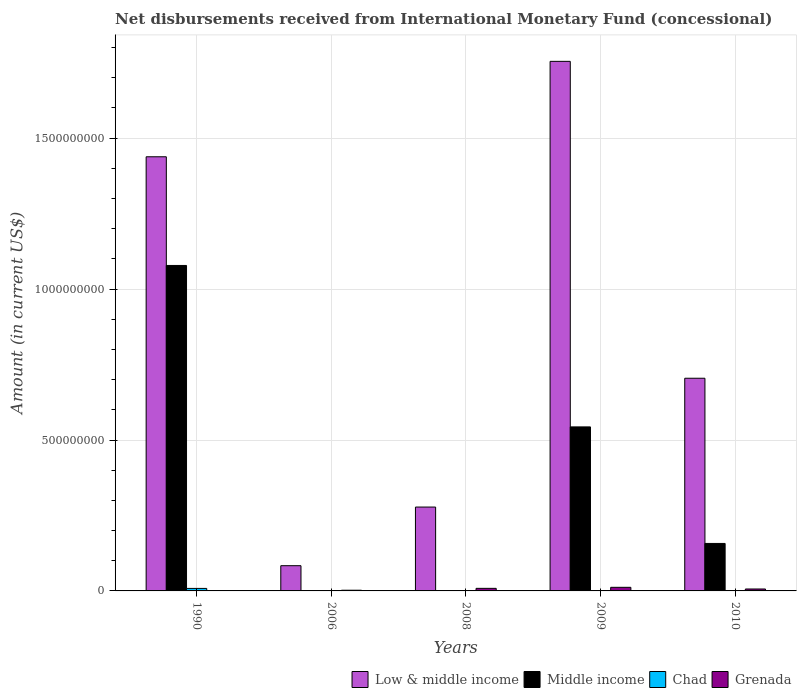How many different coloured bars are there?
Your answer should be very brief. 4. Are the number of bars per tick equal to the number of legend labels?
Ensure brevity in your answer.  No. How many bars are there on the 2nd tick from the left?
Offer a terse response. 2. How many bars are there on the 2nd tick from the right?
Your response must be concise. 3. What is the label of the 5th group of bars from the left?
Your response must be concise. 2010. In how many cases, is the number of bars for a given year not equal to the number of legend labels?
Offer a very short reply. 5. What is the amount of disbursements received from International Monetary Fund in Grenada in 2008?
Provide a succinct answer. 8.52e+06. Across all years, what is the maximum amount of disbursements received from International Monetary Fund in Low & middle income?
Keep it short and to the point. 1.75e+09. Across all years, what is the minimum amount of disbursements received from International Monetary Fund in Low & middle income?
Provide a succinct answer. 8.36e+07. In which year was the amount of disbursements received from International Monetary Fund in Chad maximum?
Keep it short and to the point. 1990. What is the total amount of disbursements received from International Monetary Fund in Chad in the graph?
Offer a terse response. 8.31e+06. What is the difference between the amount of disbursements received from International Monetary Fund in Middle income in 2009 and that in 2010?
Provide a short and direct response. 3.86e+08. What is the difference between the amount of disbursements received from International Monetary Fund in Low & middle income in 2008 and the amount of disbursements received from International Monetary Fund in Middle income in 2006?
Make the answer very short. 2.78e+08. What is the average amount of disbursements received from International Monetary Fund in Low & middle income per year?
Provide a short and direct response. 8.52e+08. In the year 2010, what is the difference between the amount of disbursements received from International Monetary Fund in Low & middle income and amount of disbursements received from International Monetary Fund in Grenada?
Provide a succinct answer. 6.98e+08. In how many years, is the amount of disbursements received from International Monetary Fund in Low & middle income greater than 900000000 US$?
Ensure brevity in your answer.  2. What is the ratio of the amount of disbursements received from International Monetary Fund in Low & middle income in 2008 to that in 2010?
Your answer should be compact. 0.39. Is the amount of disbursements received from International Monetary Fund in Low & middle income in 1990 less than that in 2010?
Make the answer very short. No. What is the difference between the highest and the second highest amount of disbursements received from International Monetary Fund in Middle income?
Offer a terse response. 5.35e+08. What is the difference between the highest and the lowest amount of disbursements received from International Monetary Fund in Grenada?
Keep it short and to the point. 1.20e+07. In how many years, is the amount of disbursements received from International Monetary Fund in Low & middle income greater than the average amount of disbursements received from International Monetary Fund in Low & middle income taken over all years?
Ensure brevity in your answer.  2. Is it the case that in every year, the sum of the amount of disbursements received from International Monetary Fund in Low & middle income and amount of disbursements received from International Monetary Fund in Chad is greater than the sum of amount of disbursements received from International Monetary Fund in Grenada and amount of disbursements received from International Monetary Fund in Middle income?
Your response must be concise. Yes. Are all the bars in the graph horizontal?
Offer a very short reply. No. What is the difference between two consecutive major ticks on the Y-axis?
Your response must be concise. 5.00e+08. Are the values on the major ticks of Y-axis written in scientific E-notation?
Keep it short and to the point. No. How many legend labels are there?
Offer a very short reply. 4. What is the title of the graph?
Your answer should be very brief. Net disbursements received from International Monetary Fund (concessional). Does "France" appear as one of the legend labels in the graph?
Keep it short and to the point. No. What is the label or title of the Y-axis?
Make the answer very short. Amount (in current US$). What is the Amount (in current US$) of Low & middle income in 1990?
Make the answer very short. 1.44e+09. What is the Amount (in current US$) of Middle income in 1990?
Keep it short and to the point. 1.08e+09. What is the Amount (in current US$) in Chad in 1990?
Your answer should be compact. 8.31e+06. What is the Amount (in current US$) of Grenada in 1990?
Keep it short and to the point. 0. What is the Amount (in current US$) of Low & middle income in 2006?
Offer a very short reply. 8.36e+07. What is the Amount (in current US$) of Grenada in 2006?
Your response must be concise. 2.30e+06. What is the Amount (in current US$) of Low & middle income in 2008?
Give a very brief answer. 2.78e+08. What is the Amount (in current US$) of Middle income in 2008?
Your answer should be very brief. 0. What is the Amount (in current US$) of Chad in 2008?
Provide a short and direct response. 0. What is the Amount (in current US$) of Grenada in 2008?
Offer a very short reply. 8.52e+06. What is the Amount (in current US$) in Low & middle income in 2009?
Offer a very short reply. 1.75e+09. What is the Amount (in current US$) in Middle income in 2009?
Keep it short and to the point. 5.43e+08. What is the Amount (in current US$) in Grenada in 2009?
Your answer should be compact. 1.20e+07. What is the Amount (in current US$) of Low & middle income in 2010?
Offer a very short reply. 7.05e+08. What is the Amount (in current US$) in Middle income in 2010?
Make the answer very short. 1.57e+08. What is the Amount (in current US$) of Grenada in 2010?
Your answer should be very brief. 6.42e+06. Across all years, what is the maximum Amount (in current US$) of Low & middle income?
Give a very brief answer. 1.75e+09. Across all years, what is the maximum Amount (in current US$) of Middle income?
Provide a short and direct response. 1.08e+09. Across all years, what is the maximum Amount (in current US$) of Chad?
Your answer should be compact. 8.31e+06. Across all years, what is the maximum Amount (in current US$) of Grenada?
Keep it short and to the point. 1.20e+07. Across all years, what is the minimum Amount (in current US$) of Low & middle income?
Ensure brevity in your answer.  8.36e+07. What is the total Amount (in current US$) in Low & middle income in the graph?
Provide a succinct answer. 4.26e+09. What is the total Amount (in current US$) of Middle income in the graph?
Provide a succinct answer. 1.78e+09. What is the total Amount (in current US$) of Chad in the graph?
Provide a succinct answer. 8.31e+06. What is the total Amount (in current US$) of Grenada in the graph?
Make the answer very short. 2.92e+07. What is the difference between the Amount (in current US$) of Low & middle income in 1990 and that in 2006?
Provide a succinct answer. 1.35e+09. What is the difference between the Amount (in current US$) in Low & middle income in 1990 and that in 2008?
Your answer should be very brief. 1.16e+09. What is the difference between the Amount (in current US$) in Low & middle income in 1990 and that in 2009?
Make the answer very short. -3.16e+08. What is the difference between the Amount (in current US$) of Middle income in 1990 and that in 2009?
Make the answer very short. 5.35e+08. What is the difference between the Amount (in current US$) of Low & middle income in 1990 and that in 2010?
Make the answer very short. 7.34e+08. What is the difference between the Amount (in current US$) of Middle income in 1990 and that in 2010?
Your answer should be very brief. 9.21e+08. What is the difference between the Amount (in current US$) in Low & middle income in 2006 and that in 2008?
Provide a short and direct response. -1.94e+08. What is the difference between the Amount (in current US$) in Grenada in 2006 and that in 2008?
Keep it short and to the point. -6.22e+06. What is the difference between the Amount (in current US$) in Low & middle income in 2006 and that in 2009?
Offer a very short reply. -1.67e+09. What is the difference between the Amount (in current US$) in Grenada in 2006 and that in 2009?
Offer a very short reply. -9.66e+06. What is the difference between the Amount (in current US$) of Low & middle income in 2006 and that in 2010?
Provide a short and direct response. -6.21e+08. What is the difference between the Amount (in current US$) in Grenada in 2006 and that in 2010?
Your answer should be very brief. -4.12e+06. What is the difference between the Amount (in current US$) of Low & middle income in 2008 and that in 2009?
Give a very brief answer. -1.48e+09. What is the difference between the Amount (in current US$) of Grenada in 2008 and that in 2009?
Offer a very short reply. -3.43e+06. What is the difference between the Amount (in current US$) of Low & middle income in 2008 and that in 2010?
Ensure brevity in your answer.  -4.27e+08. What is the difference between the Amount (in current US$) in Grenada in 2008 and that in 2010?
Your answer should be very brief. 2.10e+06. What is the difference between the Amount (in current US$) in Low & middle income in 2009 and that in 2010?
Your response must be concise. 1.05e+09. What is the difference between the Amount (in current US$) in Middle income in 2009 and that in 2010?
Provide a succinct answer. 3.86e+08. What is the difference between the Amount (in current US$) in Grenada in 2009 and that in 2010?
Make the answer very short. 5.54e+06. What is the difference between the Amount (in current US$) of Low & middle income in 1990 and the Amount (in current US$) of Grenada in 2006?
Provide a succinct answer. 1.44e+09. What is the difference between the Amount (in current US$) of Middle income in 1990 and the Amount (in current US$) of Grenada in 2006?
Your answer should be very brief. 1.08e+09. What is the difference between the Amount (in current US$) in Chad in 1990 and the Amount (in current US$) in Grenada in 2006?
Give a very brief answer. 6.01e+06. What is the difference between the Amount (in current US$) of Low & middle income in 1990 and the Amount (in current US$) of Grenada in 2008?
Offer a terse response. 1.43e+09. What is the difference between the Amount (in current US$) of Middle income in 1990 and the Amount (in current US$) of Grenada in 2008?
Keep it short and to the point. 1.07e+09. What is the difference between the Amount (in current US$) in Chad in 1990 and the Amount (in current US$) in Grenada in 2008?
Give a very brief answer. -2.11e+05. What is the difference between the Amount (in current US$) of Low & middle income in 1990 and the Amount (in current US$) of Middle income in 2009?
Your answer should be very brief. 8.95e+08. What is the difference between the Amount (in current US$) in Low & middle income in 1990 and the Amount (in current US$) in Grenada in 2009?
Keep it short and to the point. 1.43e+09. What is the difference between the Amount (in current US$) of Middle income in 1990 and the Amount (in current US$) of Grenada in 2009?
Your answer should be very brief. 1.07e+09. What is the difference between the Amount (in current US$) of Chad in 1990 and the Amount (in current US$) of Grenada in 2009?
Provide a succinct answer. -3.64e+06. What is the difference between the Amount (in current US$) in Low & middle income in 1990 and the Amount (in current US$) in Middle income in 2010?
Your response must be concise. 1.28e+09. What is the difference between the Amount (in current US$) in Low & middle income in 1990 and the Amount (in current US$) in Grenada in 2010?
Give a very brief answer. 1.43e+09. What is the difference between the Amount (in current US$) of Middle income in 1990 and the Amount (in current US$) of Grenada in 2010?
Offer a very short reply. 1.07e+09. What is the difference between the Amount (in current US$) in Chad in 1990 and the Amount (in current US$) in Grenada in 2010?
Your response must be concise. 1.89e+06. What is the difference between the Amount (in current US$) of Low & middle income in 2006 and the Amount (in current US$) of Grenada in 2008?
Give a very brief answer. 7.50e+07. What is the difference between the Amount (in current US$) in Low & middle income in 2006 and the Amount (in current US$) in Middle income in 2009?
Offer a terse response. -4.60e+08. What is the difference between the Amount (in current US$) in Low & middle income in 2006 and the Amount (in current US$) in Grenada in 2009?
Give a very brief answer. 7.16e+07. What is the difference between the Amount (in current US$) of Low & middle income in 2006 and the Amount (in current US$) of Middle income in 2010?
Your response must be concise. -7.37e+07. What is the difference between the Amount (in current US$) of Low & middle income in 2006 and the Amount (in current US$) of Grenada in 2010?
Provide a succinct answer. 7.71e+07. What is the difference between the Amount (in current US$) of Low & middle income in 2008 and the Amount (in current US$) of Middle income in 2009?
Your answer should be compact. -2.66e+08. What is the difference between the Amount (in current US$) of Low & middle income in 2008 and the Amount (in current US$) of Grenada in 2009?
Make the answer very short. 2.66e+08. What is the difference between the Amount (in current US$) of Low & middle income in 2008 and the Amount (in current US$) of Middle income in 2010?
Your response must be concise. 1.21e+08. What is the difference between the Amount (in current US$) in Low & middle income in 2008 and the Amount (in current US$) in Grenada in 2010?
Your answer should be very brief. 2.71e+08. What is the difference between the Amount (in current US$) in Low & middle income in 2009 and the Amount (in current US$) in Middle income in 2010?
Provide a short and direct response. 1.60e+09. What is the difference between the Amount (in current US$) of Low & middle income in 2009 and the Amount (in current US$) of Grenada in 2010?
Provide a short and direct response. 1.75e+09. What is the difference between the Amount (in current US$) of Middle income in 2009 and the Amount (in current US$) of Grenada in 2010?
Keep it short and to the point. 5.37e+08. What is the average Amount (in current US$) of Low & middle income per year?
Offer a very short reply. 8.52e+08. What is the average Amount (in current US$) of Middle income per year?
Give a very brief answer. 3.56e+08. What is the average Amount (in current US$) in Chad per year?
Give a very brief answer. 1.66e+06. What is the average Amount (in current US$) in Grenada per year?
Offer a very short reply. 5.84e+06. In the year 1990, what is the difference between the Amount (in current US$) of Low & middle income and Amount (in current US$) of Middle income?
Ensure brevity in your answer.  3.60e+08. In the year 1990, what is the difference between the Amount (in current US$) of Low & middle income and Amount (in current US$) of Chad?
Ensure brevity in your answer.  1.43e+09. In the year 1990, what is the difference between the Amount (in current US$) in Middle income and Amount (in current US$) in Chad?
Make the answer very short. 1.07e+09. In the year 2006, what is the difference between the Amount (in current US$) of Low & middle income and Amount (in current US$) of Grenada?
Your answer should be very brief. 8.13e+07. In the year 2008, what is the difference between the Amount (in current US$) in Low & middle income and Amount (in current US$) in Grenada?
Provide a succinct answer. 2.69e+08. In the year 2009, what is the difference between the Amount (in current US$) in Low & middle income and Amount (in current US$) in Middle income?
Keep it short and to the point. 1.21e+09. In the year 2009, what is the difference between the Amount (in current US$) in Low & middle income and Amount (in current US$) in Grenada?
Your response must be concise. 1.74e+09. In the year 2009, what is the difference between the Amount (in current US$) in Middle income and Amount (in current US$) in Grenada?
Offer a very short reply. 5.31e+08. In the year 2010, what is the difference between the Amount (in current US$) of Low & middle income and Amount (in current US$) of Middle income?
Offer a very short reply. 5.47e+08. In the year 2010, what is the difference between the Amount (in current US$) of Low & middle income and Amount (in current US$) of Grenada?
Give a very brief answer. 6.98e+08. In the year 2010, what is the difference between the Amount (in current US$) in Middle income and Amount (in current US$) in Grenada?
Your response must be concise. 1.51e+08. What is the ratio of the Amount (in current US$) of Low & middle income in 1990 to that in 2006?
Your answer should be compact. 17.21. What is the ratio of the Amount (in current US$) in Low & middle income in 1990 to that in 2008?
Provide a succinct answer. 5.18. What is the ratio of the Amount (in current US$) of Low & middle income in 1990 to that in 2009?
Your answer should be compact. 0.82. What is the ratio of the Amount (in current US$) of Middle income in 1990 to that in 2009?
Make the answer very short. 1.98. What is the ratio of the Amount (in current US$) of Low & middle income in 1990 to that in 2010?
Offer a very short reply. 2.04. What is the ratio of the Amount (in current US$) of Middle income in 1990 to that in 2010?
Keep it short and to the point. 6.86. What is the ratio of the Amount (in current US$) in Low & middle income in 2006 to that in 2008?
Your answer should be compact. 0.3. What is the ratio of the Amount (in current US$) of Grenada in 2006 to that in 2008?
Your response must be concise. 0.27. What is the ratio of the Amount (in current US$) of Low & middle income in 2006 to that in 2009?
Provide a succinct answer. 0.05. What is the ratio of the Amount (in current US$) in Grenada in 2006 to that in 2009?
Keep it short and to the point. 0.19. What is the ratio of the Amount (in current US$) of Low & middle income in 2006 to that in 2010?
Provide a short and direct response. 0.12. What is the ratio of the Amount (in current US$) in Grenada in 2006 to that in 2010?
Provide a short and direct response. 0.36. What is the ratio of the Amount (in current US$) of Low & middle income in 2008 to that in 2009?
Your response must be concise. 0.16. What is the ratio of the Amount (in current US$) of Grenada in 2008 to that in 2009?
Give a very brief answer. 0.71. What is the ratio of the Amount (in current US$) of Low & middle income in 2008 to that in 2010?
Your response must be concise. 0.39. What is the ratio of the Amount (in current US$) in Grenada in 2008 to that in 2010?
Offer a terse response. 1.33. What is the ratio of the Amount (in current US$) in Low & middle income in 2009 to that in 2010?
Keep it short and to the point. 2.49. What is the ratio of the Amount (in current US$) in Middle income in 2009 to that in 2010?
Offer a terse response. 3.46. What is the ratio of the Amount (in current US$) in Grenada in 2009 to that in 2010?
Offer a very short reply. 1.86. What is the difference between the highest and the second highest Amount (in current US$) of Low & middle income?
Your answer should be compact. 3.16e+08. What is the difference between the highest and the second highest Amount (in current US$) of Middle income?
Give a very brief answer. 5.35e+08. What is the difference between the highest and the second highest Amount (in current US$) of Grenada?
Provide a succinct answer. 3.43e+06. What is the difference between the highest and the lowest Amount (in current US$) of Low & middle income?
Your response must be concise. 1.67e+09. What is the difference between the highest and the lowest Amount (in current US$) in Middle income?
Ensure brevity in your answer.  1.08e+09. What is the difference between the highest and the lowest Amount (in current US$) of Chad?
Keep it short and to the point. 8.31e+06. What is the difference between the highest and the lowest Amount (in current US$) in Grenada?
Your response must be concise. 1.20e+07. 